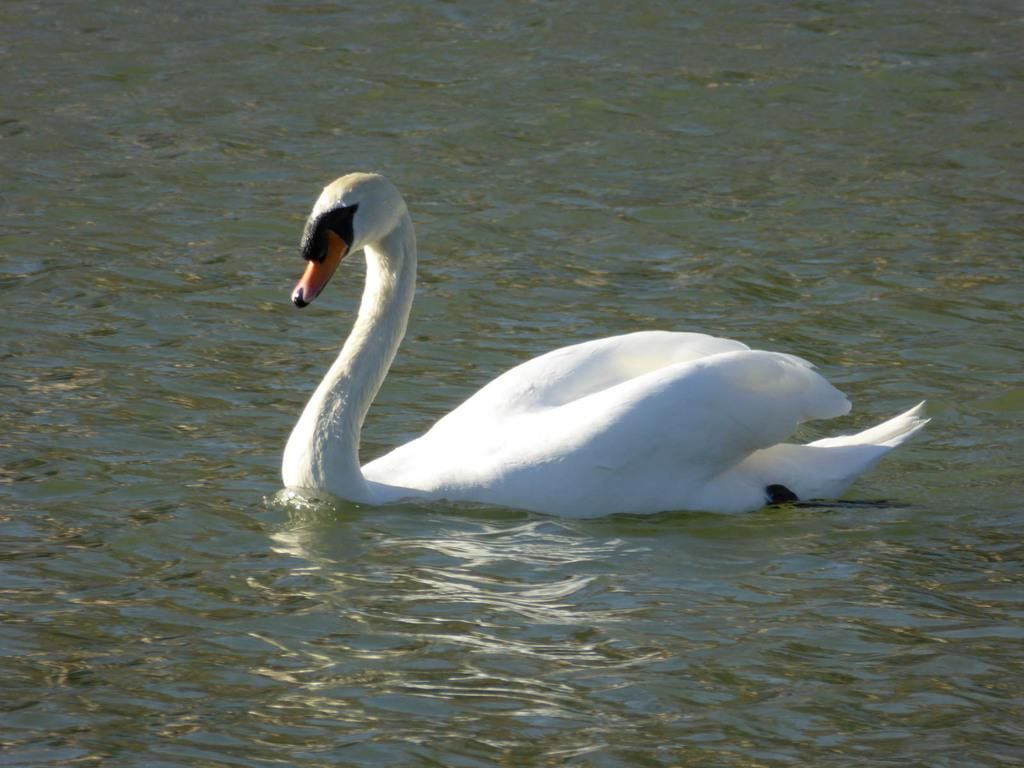What type of animal is in the image? There is a big white duck in the image. What is the duck doing in the image? The duck is swimming in the lake water. What color is the patch on the duck's wing in the image? There is no patch visible on the duck's wing in the image. 